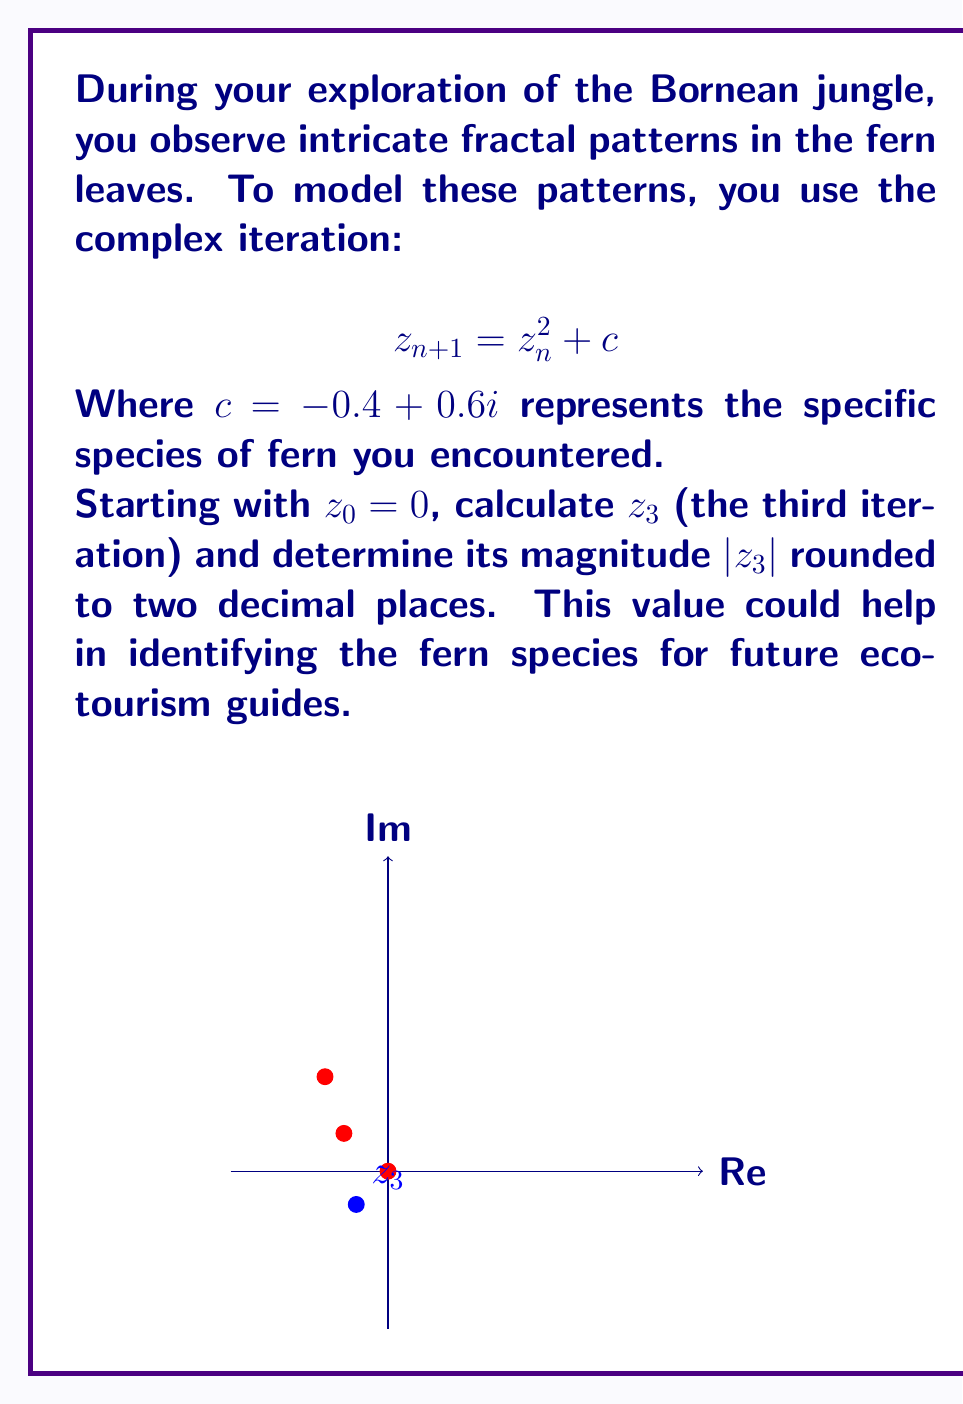Give your solution to this math problem. Let's calculate $z_3$ step by step:

1) We start with $z_0 = 0$ and $c = -0.4 + 0.6i$

2) Calculate $z_1$:
   $$z_1 = z_0^2 + c = 0^2 + (-0.4 + 0.6i) = -0.4 + 0.6i$$

3) Calculate $z_2$:
   $$\begin{aligned}
   z_2 &= z_1^2 + c \\
   &= (-0.4 + 0.6i)^2 + (-0.4 + 0.6i) \\
   &= (0.16 - 0.48i + 0.36i^2) + (-0.4 + 0.6i) \\
   &= (0.16 - 0.48i - 0.36) + (-0.4 + 0.6i) \\
   &= -0.6 + 0.12i
   \end{aligned}$$

4) Calculate $z_3$:
   $$\begin{aligned}
   z_3 &= z_2^2 + c \\
   &= (-0.6 + 0.12i)^2 + (-0.4 + 0.6i) \\
   &= (0.36 - 0.144i + 0.0144i^2) + (-0.4 + 0.6i) \\
   &= (0.36 - 0.144i - 0.0144) + (-0.4 + 0.6i) \\
   &= -0.0544 + 0.456i
   \end{aligned}$$

5) Calculate $|z_3|$:
   $$\begin{aligned}
   |z_3| &= \sqrt{(-0.0544)^2 + (0.456)^2} \\
   &= \sqrt{0.002959 + 0.207936} \\
   &= \sqrt{0.210895} \\
   &\approx 0.4592
   \end{aligned}$$

6) Rounding to two decimal places: $0.46$
Answer: $0.46$ 